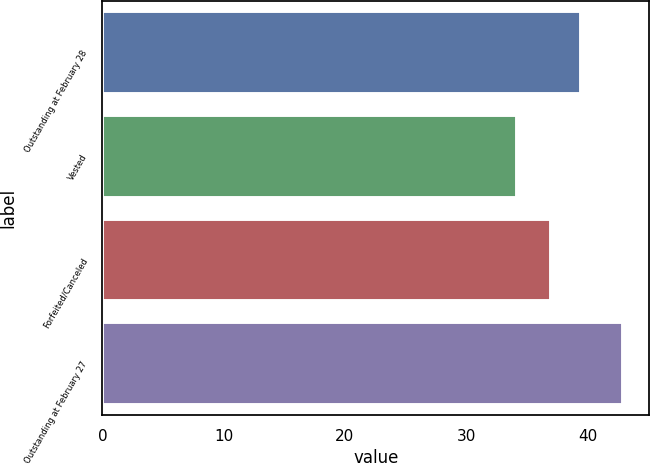Convert chart. <chart><loc_0><loc_0><loc_500><loc_500><bar_chart><fcel>Outstanding at February 28<fcel>Vested<fcel>Forfeited/Canceled<fcel>Outstanding at February 27<nl><fcel>39.5<fcel>34.17<fcel>37<fcel>42.97<nl></chart> 